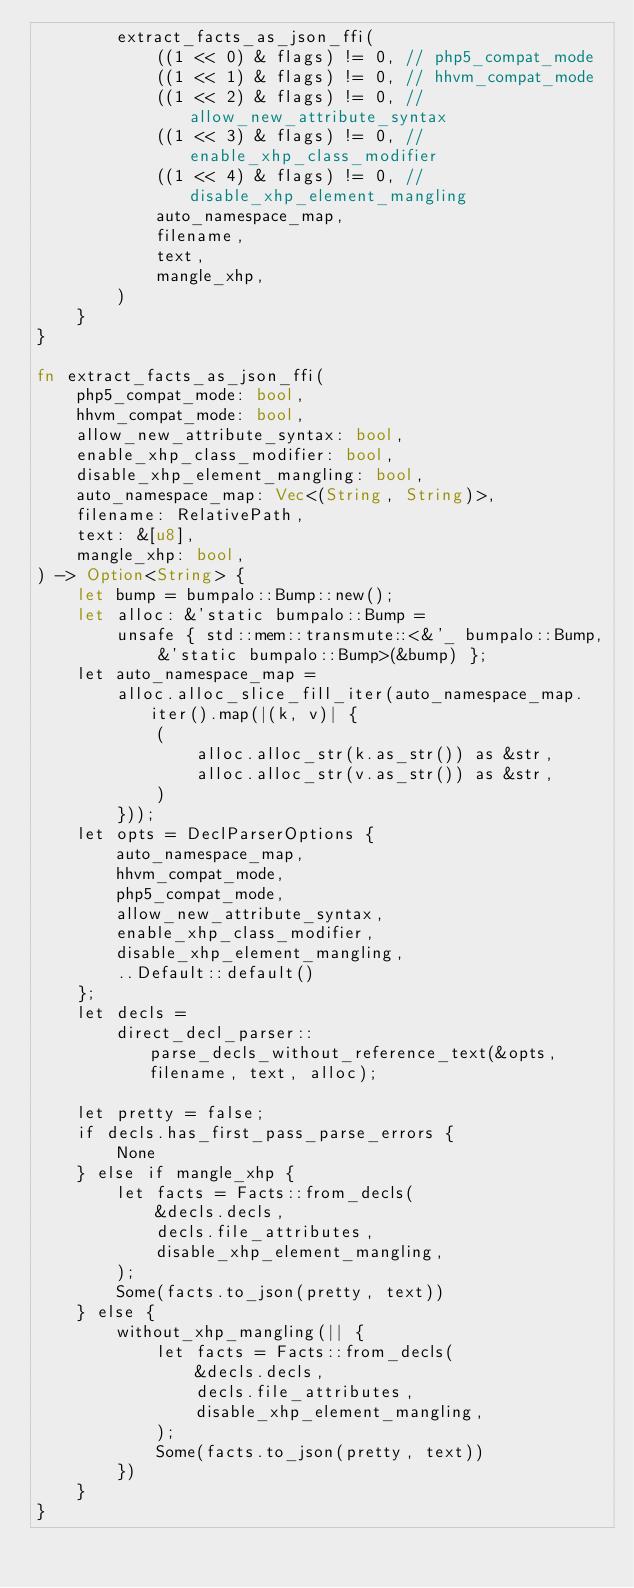Convert code to text. <code><loc_0><loc_0><loc_500><loc_500><_Rust_>        extract_facts_as_json_ffi(
            ((1 << 0) & flags) != 0, // php5_compat_mode
            ((1 << 1) & flags) != 0, // hhvm_compat_mode
            ((1 << 2) & flags) != 0, // allow_new_attribute_syntax
            ((1 << 3) & flags) != 0, // enable_xhp_class_modifier
            ((1 << 4) & flags) != 0, // disable_xhp_element_mangling
            auto_namespace_map,
            filename,
            text,
            mangle_xhp,
        )
    }
}

fn extract_facts_as_json_ffi(
    php5_compat_mode: bool,
    hhvm_compat_mode: bool,
    allow_new_attribute_syntax: bool,
    enable_xhp_class_modifier: bool,
    disable_xhp_element_mangling: bool,
    auto_namespace_map: Vec<(String, String)>,
    filename: RelativePath,
    text: &[u8],
    mangle_xhp: bool,
) -> Option<String> {
    let bump = bumpalo::Bump::new();
    let alloc: &'static bumpalo::Bump =
        unsafe { std::mem::transmute::<&'_ bumpalo::Bump, &'static bumpalo::Bump>(&bump) };
    let auto_namespace_map =
        alloc.alloc_slice_fill_iter(auto_namespace_map.iter().map(|(k, v)| {
            (
                alloc.alloc_str(k.as_str()) as &str,
                alloc.alloc_str(v.as_str()) as &str,
            )
        }));
    let opts = DeclParserOptions {
        auto_namespace_map,
        hhvm_compat_mode,
        php5_compat_mode,
        allow_new_attribute_syntax,
        enable_xhp_class_modifier,
        disable_xhp_element_mangling,
        ..Default::default()
    };
    let decls =
        direct_decl_parser::parse_decls_without_reference_text(&opts, filename, text, alloc);

    let pretty = false;
    if decls.has_first_pass_parse_errors {
        None
    } else if mangle_xhp {
        let facts = Facts::from_decls(
            &decls.decls,
            decls.file_attributes,
            disable_xhp_element_mangling,
        );
        Some(facts.to_json(pretty, text))
    } else {
        without_xhp_mangling(|| {
            let facts = Facts::from_decls(
                &decls.decls,
                decls.file_attributes,
                disable_xhp_element_mangling,
            );
            Some(facts.to_json(pretty, text))
        })
    }
}
</code> 